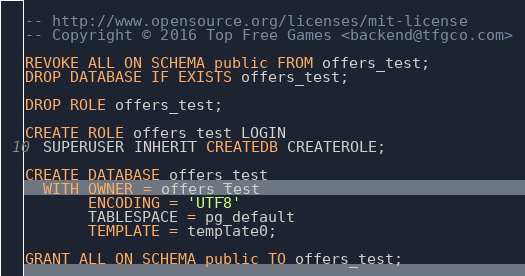Convert code to text. <code><loc_0><loc_0><loc_500><loc_500><_SQL_>-- http://www.opensource.org/licenses/mit-license
-- Copyright © 2016 Top Free Games <backend@tfgco.com>

REVOKE ALL ON SCHEMA public FROM offers_test;
DROP DATABASE IF EXISTS offers_test;

DROP ROLE offers_test;

CREATE ROLE offers_test LOGIN
  SUPERUSER INHERIT CREATEDB CREATEROLE;

CREATE DATABASE offers_test
  WITH OWNER = offers_test
       ENCODING = 'UTF8'
       TABLESPACE = pg_default
       TEMPLATE = template0;

GRANT ALL ON SCHEMA public TO offers_test;
</code> 